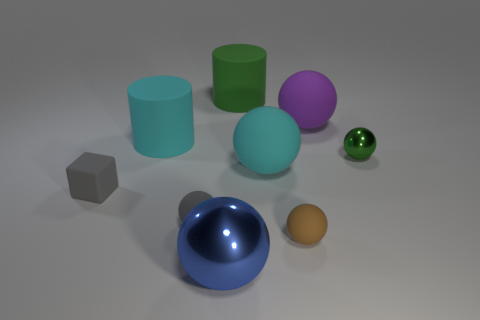Subtract all brown rubber spheres. How many spheres are left? 5 Subtract all brown balls. How many balls are left? 5 Subtract all cylinders. How many objects are left? 7 Subtract 0 red cubes. How many objects are left? 9 Subtract 2 cylinders. How many cylinders are left? 0 Subtract all purple cubes. Subtract all yellow spheres. How many cubes are left? 1 Subtract all purple balls. How many cyan cylinders are left? 1 Subtract all tiny purple objects. Subtract all cyan rubber objects. How many objects are left? 7 Add 7 blue balls. How many blue balls are left? 8 Add 2 gray metal balls. How many gray metal balls exist? 2 